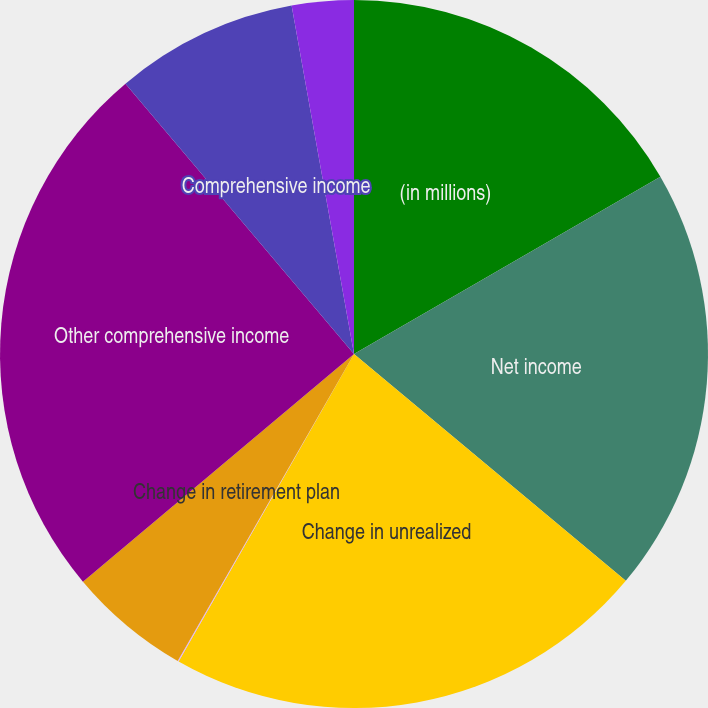Convert chart to OTSL. <chart><loc_0><loc_0><loc_500><loc_500><pie_chart><fcel>(in millions)<fcel>Net income<fcel>Change in unrealized<fcel>Change in net derivative gains<fcel>Change in retirement plan<fcel>Other comprehensive income<fcel>Comprehensive income<fcel>Comprehensive income (loss)<nl><fcel>16.65%<fcel>19.42%<fcel>22.18%<fcel>0.05%<fcel>5.58%<fcel>24.95%<fcel>8.35%<fcel>2.82%<nl></chart> 